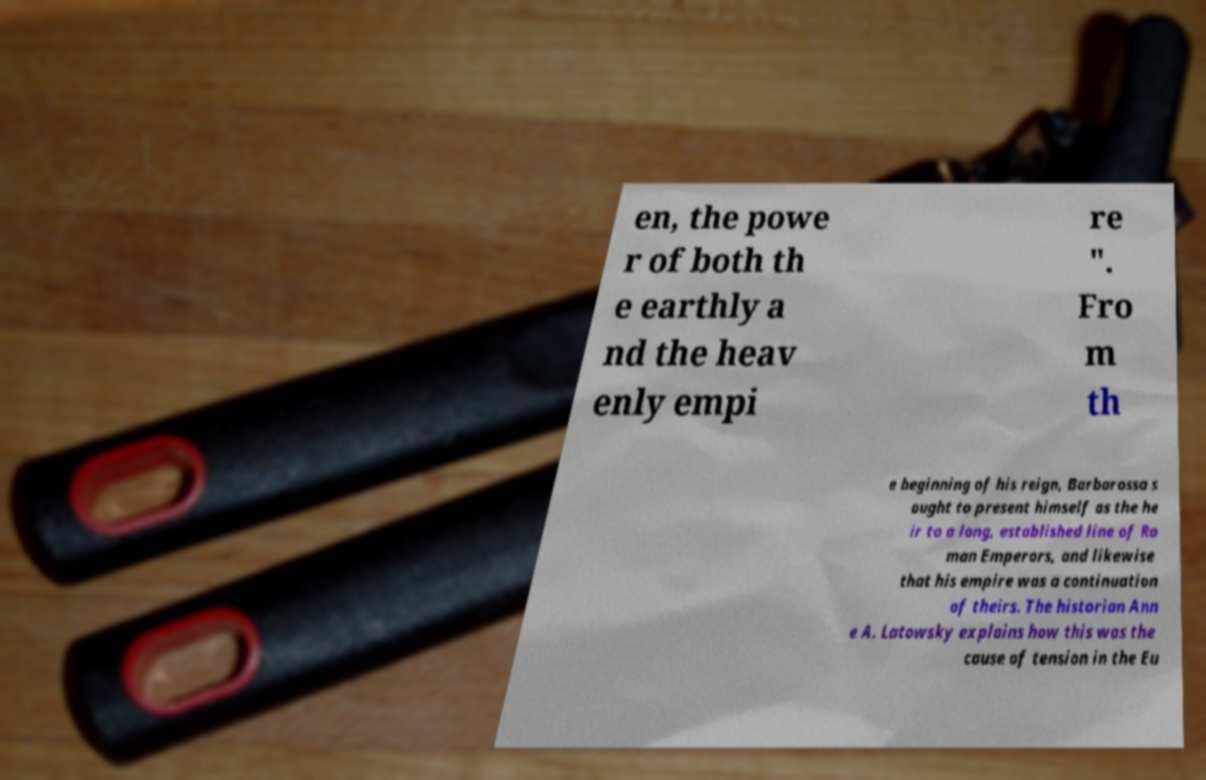For documentation purposes, I need the text within this image transcribed. Could you provide that? en, the powe r of both th e earthly a nd the heav enly empi re ". Fro m th e beginning of his reign, Barbarossa s ought to present himself as the he ir to a long, established line of Ro man Emperors, and likewise that his empire was a continuation of theirs. The historian Ann e A. Latowsky explains how this was the cause of tension in the Eu 